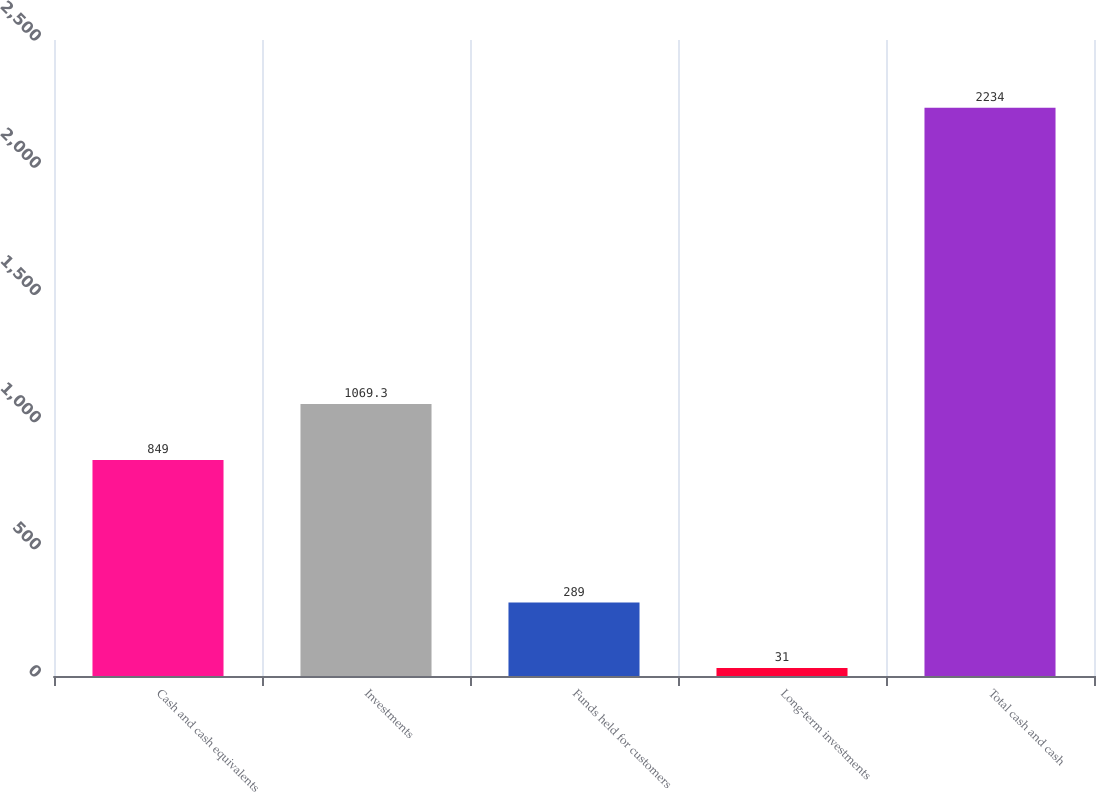<chart> <loc_0><loc_0><loc_500><loc_500><bar_chart><fcel>Cash and cash equivalents<fcel>Investments<fcel>Funds held for customers<fcel>Long-term investments<fcel>Total cash and cash<nl><fcel>849<fcel>1069.3<fcel>289<fcel>31<fcel>2234<nl></chart> 